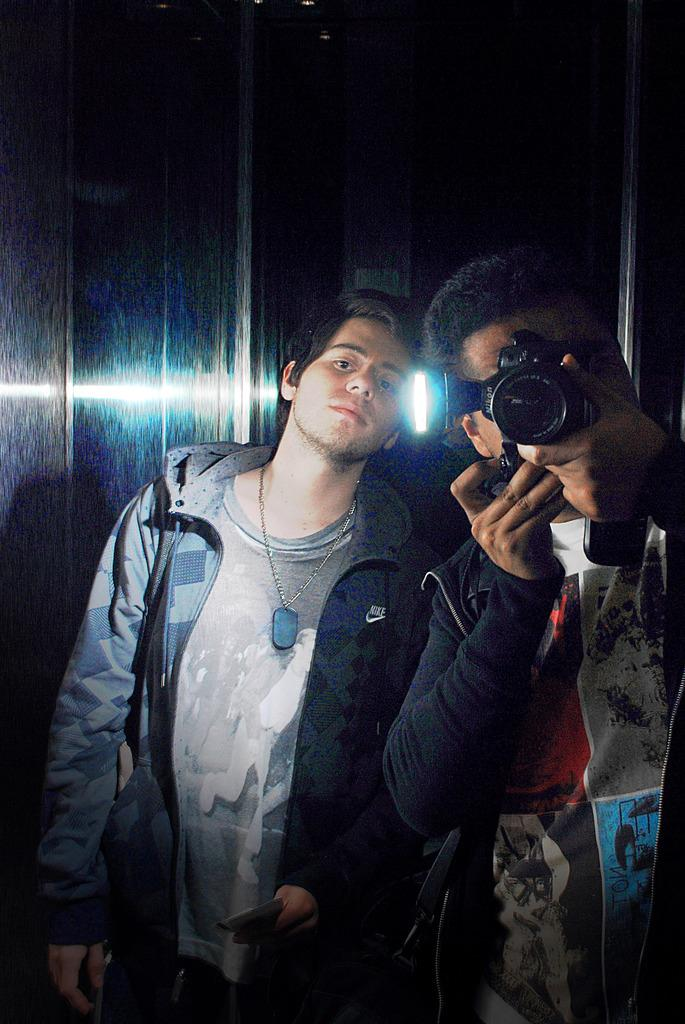How many people are in the image? There are two men in the image. What is one of the men doing in the image? One man is holding a camera and taking pictures. Can you describe the clothing of the other man? The other man is wearing a jerkin. What is the position of the other man in the image? The other man is standing. What type of letter is the beginner using to fuel the camera in the image? There is no letter or fuel present in the image, and the camera does not require fuel to operate. 